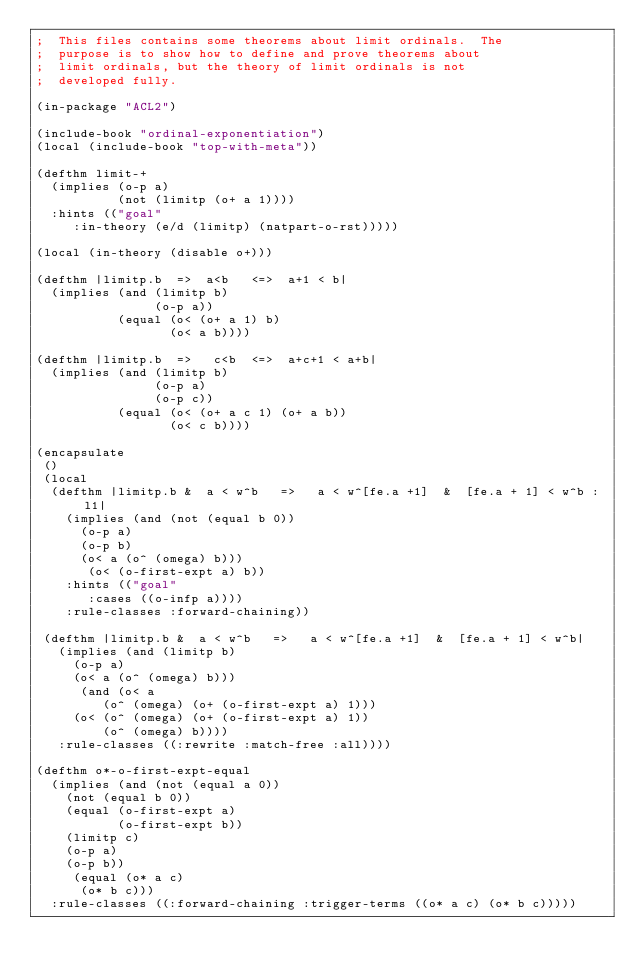Convert code to text. <code><loc_0><loc_0><loc_500><loc_500><_Lisp_>;  This files contains some theorems about limit ordinals.  The
;  purpose is to show how to define and prove theorems about
;  limit ordinals, but the theory of limit ordinals is not
;  developed fully.

(in-package "ACL2")

(include-book "ordinal-exponentiation")
(local (include-book "top-with-meta"))

(defthm limit-+
  (implies (o-p a)
           (not (limitp (o+ a 1))))
  :hints (("goal"
	   :in-theory (e/d (limitp) (natpart-o-rst)))))

(local (in-theory (disable o+)))

(defthm |limitp.b  =>  a<b   <=>  a+1 < b|
  (implies (and (limitp b)
                (o-p a))
           (equal (o< (o+ a 1) b)
                  (o< a b))))

(defthm |limitp.b  =>   c<b  <=>  a+c+1 < a+b|
  (implies (and (limitp b)
                (o-p a)
                (o-p c))
           (equal (o< (o+ a c 1) (o+ a b))
                  (o< c b))))

(encapsulate
 ()
 (local
  (defthm |limitp.b &  a < w^b   =>   a < w^[fe.a +1]  &  [fe.a + 1] < w^b :l1|
    (implies (and (not (equal b 0))
		  (o-p a)
		  (o-p b)
		  (o< a (o^ (omega) b)))
	     (o< (o-first-expt a) b))
    :hints (("goal"
	     :cases ((o-infp a))))
    :rule-classes :forward-chaining))

 (defthm |limitp.b &  a < w^b   =>   a < w^[fe.a +1]  &  [fe.a + 1] < w^b|
   (implies (and (limitp b)
		 (o-p a)
		 (o< a (o^ (omega) b)))
	    (and (o< a
		     (o^ (omega) (o+ (o-first-expt a) 1)))
		 (o< (o^ (omega) (o+ (o-first-expt a) 1))
		     (o^ (omega) b))))
   :rule-classes ((:rewrite :match-free :all))))

(defthm o*-o-first-expt-equal
  (implies (and (not (equal a 0))
		(not (equal b 0))
		(equal (o-first-expt a)
		       (o-first-expt b))
		(limitp c)
		(o-p a)
		(o-p b))
	   (equal (o* a c)
		  (o* b c)))
  :rule-classes ((:forward-chaining :trigger-terms ((o* a c) (o* b c)))))
</code> 